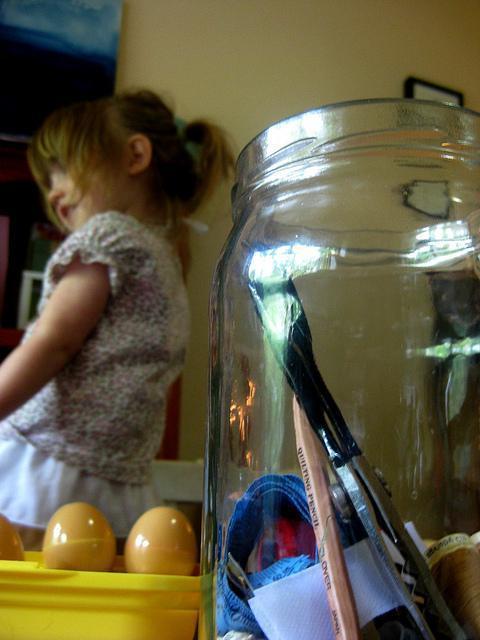How many people are in the picture?
Give a very brief answer. 1. How many elephants are facing toward the camera?
Give a very brief answer. 0. 